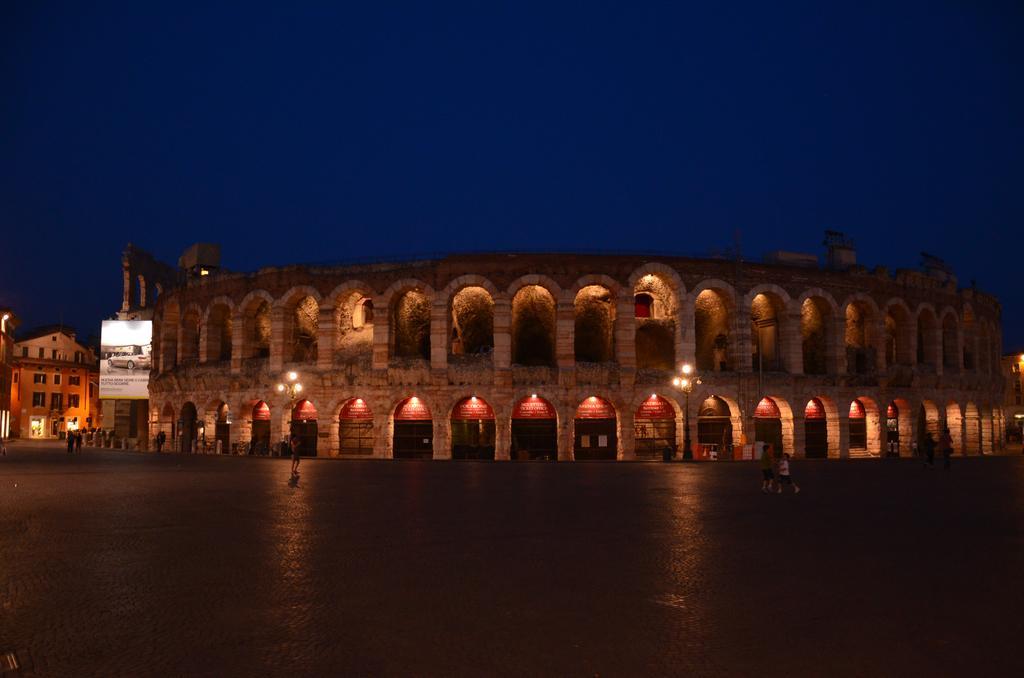Describe this image in one or two sentences. In this image we can see a few buildings and also we can see some people on the road, there are some pillars, lights and board with text and image, in the background, we can see the sky. 